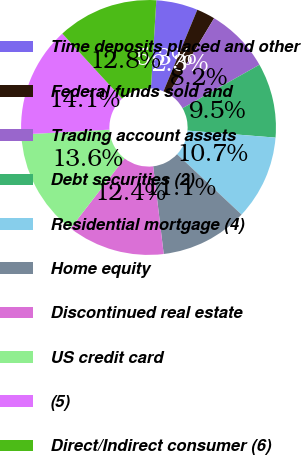Convert chart. <chart><loc_0><loc_0><loc_500><loc_500><pie_chart><fcel>Time deposits placed and other<fcel>Federal funds sold and<fcel>Trading account assets<fcel>Debt securities (2)<fcel>Residential mortgage (4)<fcel>Home equity<fcel>Discontinued real estate<fcel>US credit card<fcel>(5)<fcel>Direct/Indirect consumer (6)<nl><fcel>5.28%<fcel>2.35%<fcel>8.2%<fcel>9.46%<fcel>10.71%<fcel>11.12%<fcel>12.38%<fcel>13.64%<fcel>14.06%<fcel>12.8%<nl></chart> 